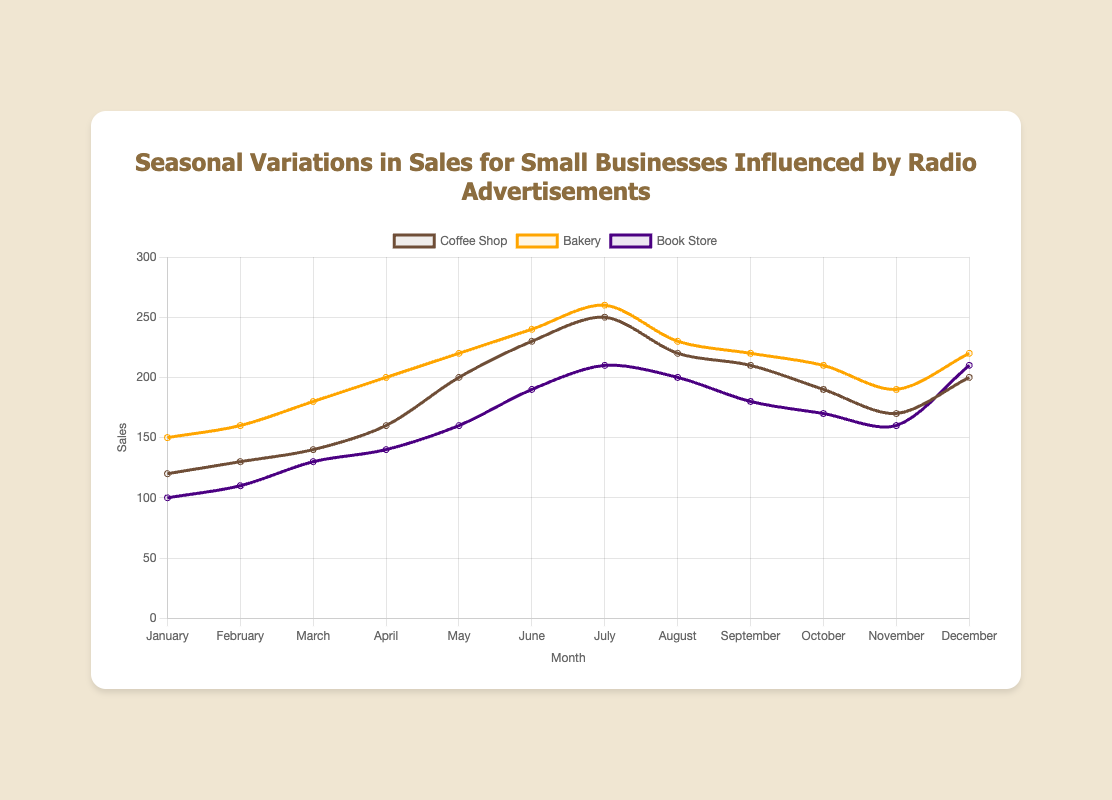Which month had the highest sales for the Coffee Shop? According to the line plot, the Coffee Shop had the highest sales in July, as it shows the peak value for that line.
Answer: July Which business had the lowest sales in January? In January, the Book Store had the lowest sales. By comparing the heights of the lines for each business in January, the Book Store's line is the lowest.
Answer: Book Store What is the difference in sales between the Coffee Shop and the Bakery in March? In March, the Coffee Shop had 140 sales and the Bakery had 180 sales. The difference is calculated as 180 - 140.
Answer: 40 During which months did the Bakery have sales equal to or greater than 200? By looking at the line for the Bakery, it breached the 200 sales mark from April to July and again in December.
Answer: April, May, June, July, December How many months did the Book Store have sales greater than or equal to 200? The Book Store had sales greater than or equal to 200 in four months: June, July, August, and December. This is identified by checking the data points of the Book Store's line.
Answer: 4 What was the total sales for the Coffee Shop in the first quarter of the year? The first quarter includes January, February, and March. Summing up the Coffee Shop sales for these months: 120 + 130 + 140.
Answer: 390 Which business saw the largest increase in sales from February to March? The Bakery's sales increased from 160 to 180, the Coffee Shop's from 130 to 140, and the Book Store's from 110 to 130. The largest increase is for the Book Store with 20.
Answer: Book Store What average sales did the Bakery have from May to August? Average sales is calculated by summing sales from May (220), June (240), July (260), and August (230) and then dividing by 4: (220 + 240 + 260 + 230)/4.
Answer: 237.5 Which business experienced the steepest decline in sales from July to August? By observing the slope of lines from July to August: Coffee Shop dropped from 250 to 220, Bakery from 260 to 230, and Book Store from 210 to 200. The Bakery experienced the steepest decline with a decrease of 30.
Answer: Bakery In which month did the Coffee Shop experience the biggest increase in sales compared to the previous month? The largest increase for the Coffee Shop occurred between April (160) to May (200), an increase of 40. Observing each month-to-month change confirms this.
Answer: May 